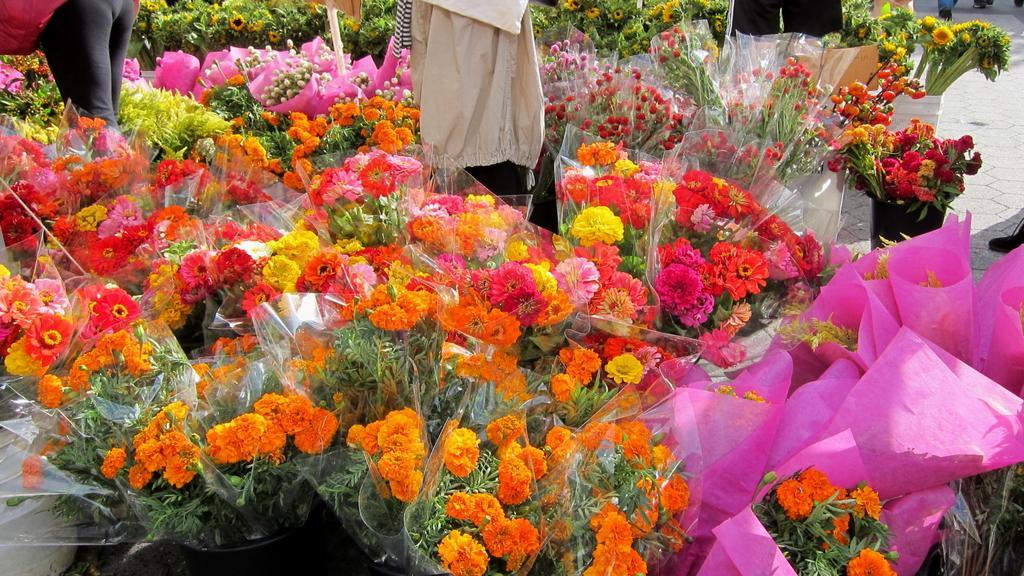How would you summarize this image in a sentence or two? These are flowers. 